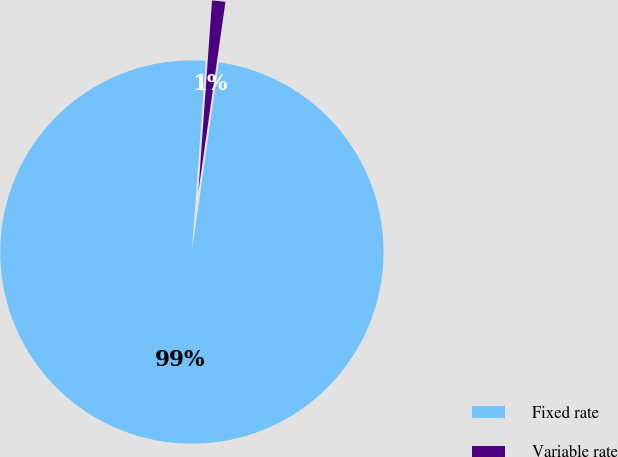Convert chart to OTSL. <chart><loc_0><loc_0><loc_500><loc_500><pie_chart><fcel>Fixed rate<fcel>Variable rate<nl><fcel>98.88%<fcel>1.12%<nl></chart> 